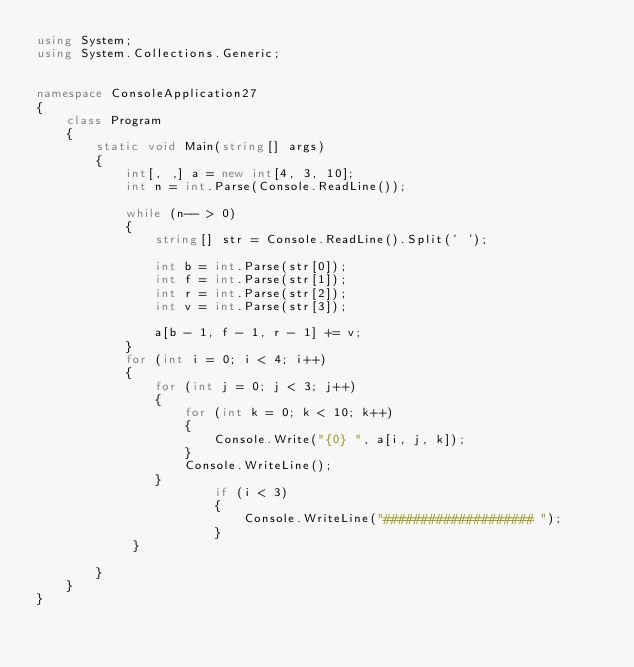Convert code to text. <code><loc_0><loc_0><loc_500><loc_500><_C#_>using System;
using System.Collections.Generic;


namespace ConsoleApplication27
{
    class Program
    {
        static void Main(string[] args)
        {
            int[, ,] a = new int[4, 3, 10];
            int n = int.Parse(Console.ReadLine());

            while (n-- > 0)
            {
                string[] str = Console.ReadLine().Split(' ');

                int b = int.Parse(str[0]);
                int f = int.Parse(str[1]);
                int r = int.Parse(str[2]);
                int v = int.Parse(str[3]);

                a[b - 1, f - 1, r - 1] += v;
            }
            for (int i = 0; i < 4; i++)
            {
                for (int j = 0; j < 3; j++)
                {
                    for (int k = 0; k < 10; k++)
                    {
                        Console.Write("{0} ", a[i, j, k]);
                    }
                    Console.WriteLine();
                }
                        if (i < 3)
                        {
                            Console.WriteLine("#################### ");
                        }
             }

        }
    }
}</code> 